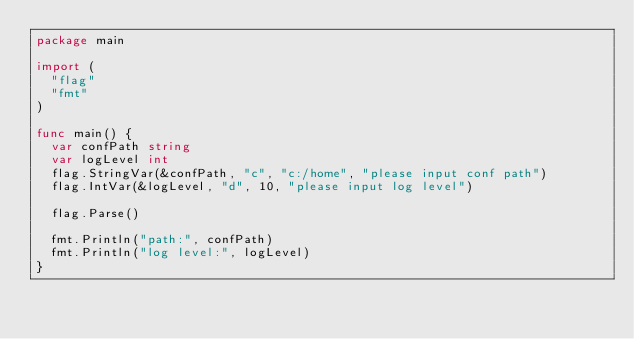<code> <loc_0><loc_0><loc_500><loc_500><_Go_>package main

import (
	"flag"
	"fmt"
)

func main() {
	var confPath string
	var logLevel int
	flag.StringVar(&confPath, "c", "c:/home", "please input conf path")
	flag.IntVar(&logLevel, "d", 10, "please input log level")

	flag.Parse()

	fmt.Println("path:", confPath)
	fmt.Println("log level:", logLevel)
}
</code> 